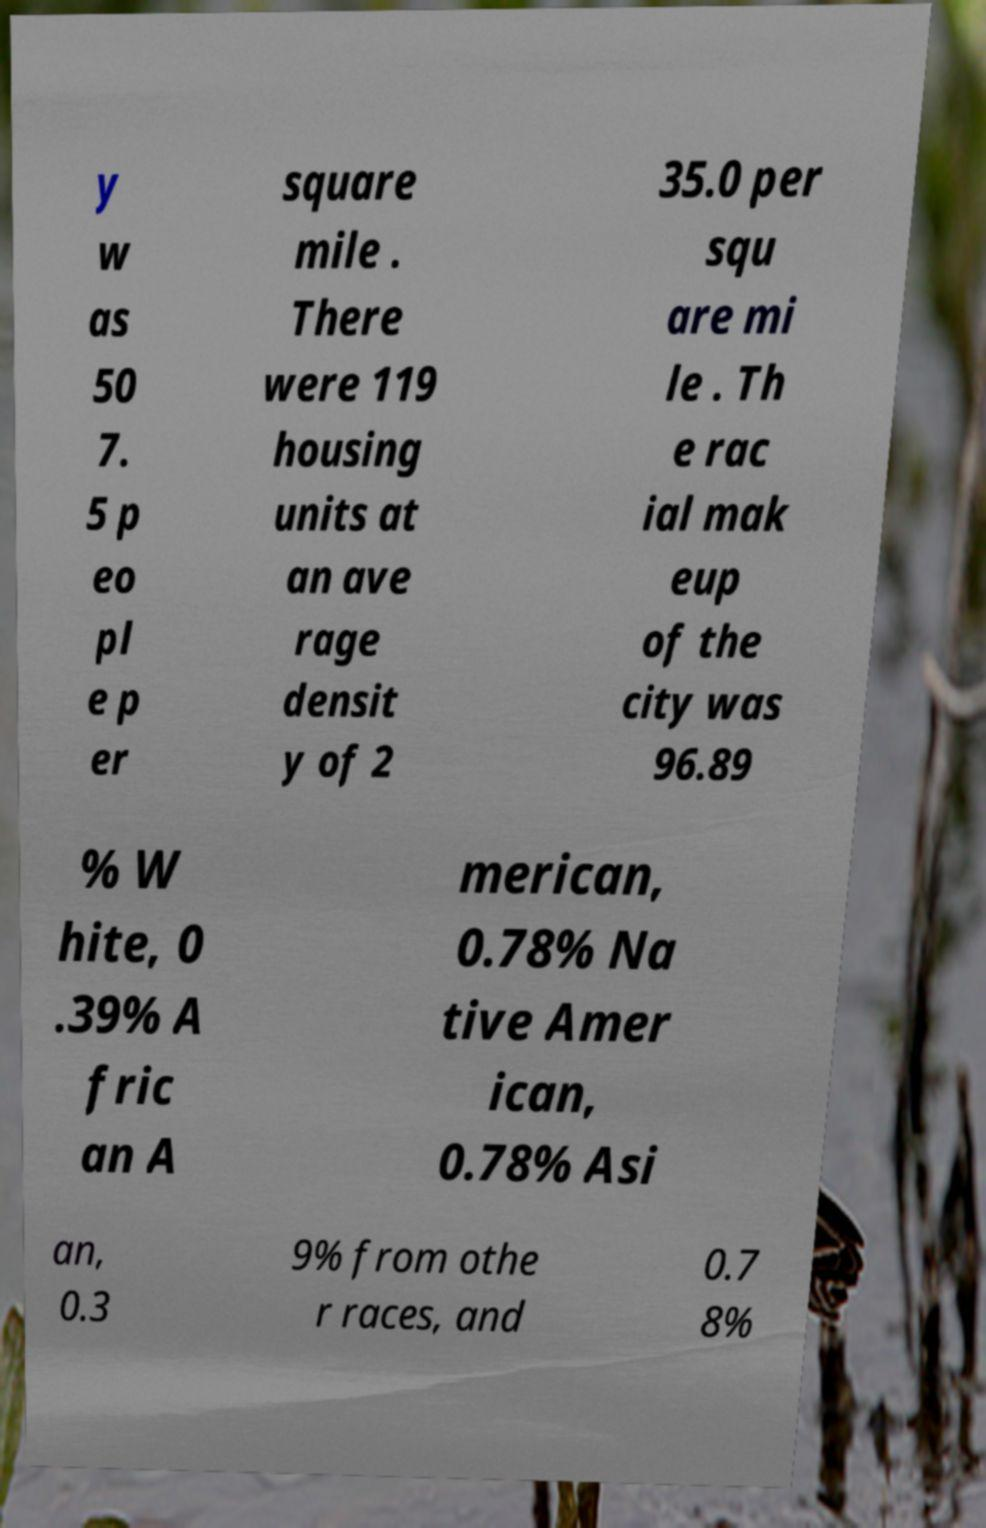There's text embedded in this image that I need extracted. Can you transcribe it verbatim? y w as 50 7. 5 p eo pl e p er square mile . There were 119 housing units at an ave rage densit y of 2 35.0 per squ are mi le . Th e rac ial mak eup of the city was 96.89 % W hite, 0 .39% A fric an A merican, 0.78% Na tive Amer ican, 0.78% Asi an, 0.3 9% from othe r races, and 0.7 8% 